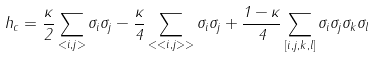Convert formula to latex. <formula><loc_0><loc_0><loc_500><loc_500>h _ { c } = \frac { \kappa } { 2 } \sum _ { < i , j > } \sigma _ { i } \sigma _ { j } - \frac { \kappa } { 4 } \sum _ { < < i , j > > } \sigma _ { i } \sigma _ { j } + \frac { 1 - \kappa } { 4 } \sum _ { [ i , j , k , l ] } \sigma _ { i } \sigma _ { j } \sigma _ { k } \sigma _ { l }</formula> 